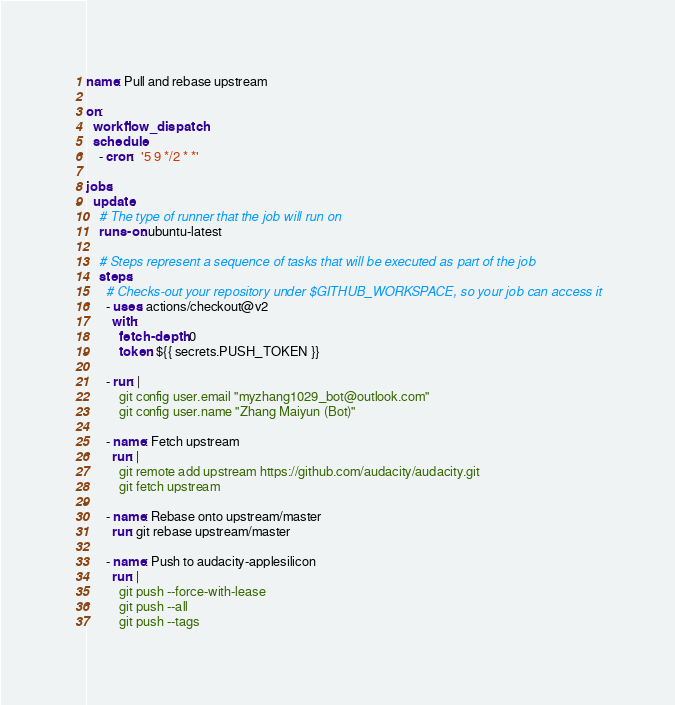<code> <loc_0><loc_0><loc_500><loc_500><_YAML_>name: Pull and rebase upstream

on:
  workflow_dispatch:
  schedule:
    - cron:  '5 9 */2 * *'

jobs:
  update:
    # The type of runner that the job will run on
    runs-on: ubuntu-latest

    # Steps represent a sequence of tasks that will be executed as part of the job
    steps:
      # Checks-out your repository under $GITHUB_WORKSPACE, so your job can access it
      - uses: actions/checkout@v2
        with:
          fetch-depth: 0
          token: ${{ secrets.PUSH_TOKEN }}

      - run: |
          git config user.email "myzhang1029_bot@outlook.com"
          git config user.name "Zhang Maiyun (Bot)"

      - name: Fetch upstream
        run: |
          git remote add upstream https://github.com/audacity/audacity.git
          git fetch upstream
  
      - name: Rebase onto upstream/master
        run: git rebase upstream/master
          
      - name: Push to audacity-applesilicon
        run: |
          git push --force-with-lease
          git push --all
          git push --tags
</code> 